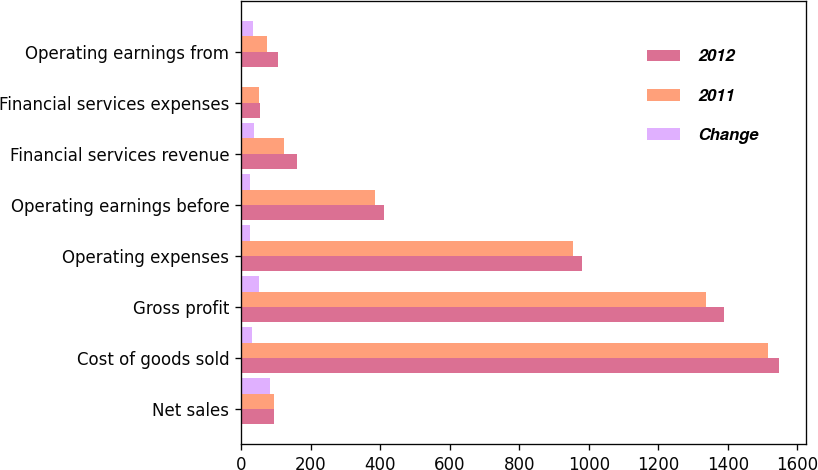Convert chart. <chart><loc_0><loc_0><loc_500><loc_500><stacked_bar_chart><ecel><fcel>Net sales<fcel>Cost of goods sold<fcel>Gross profit<fcel>Operating expenses<fcel>Operating earnings before<fcel>Financial services revenue<fcel>Financial services expenses<fcel>Operating earnings from<nl><fcel>2012<fcel>95.2<fcel>1547.9<fcel>1390<fcel>980.3<fcel>409.7<fcel>161.3<fcel>54.6<fcel>106.7<nl><fcel>2011<fcel>95.2<fcel>1516.3<fcel>1337.9<fcel>953.7<fcel>384.2<fcel>124.3<fcel>51.4<fcel>72.9<nl><fcel>Change<fcel>83.7<fcel>31.6<fcel>52.1<fcel>26.6<fcel>25.5<fcel>37<fcel>3.2<fcel>33.8<nl></chart> 